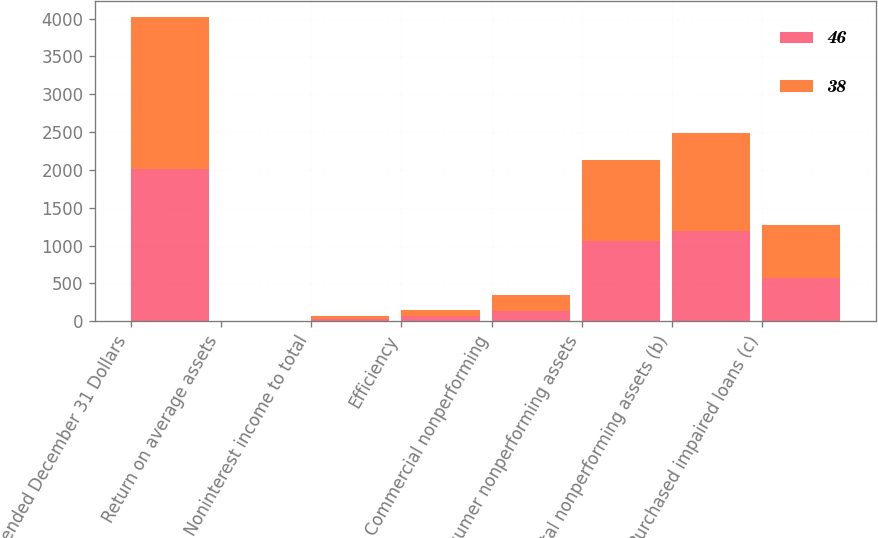<chart> <loc_0><loc_0><loc_500><loc_500><stacked_bar_chart><ecel><fcel>Year ended December 31 Dollars<fcel>Return on average assets<fcel>Noninterest income to total<fcel>Efficiency<fcel>Commercial nonperforming<fcel>Consumer nonperforming assets<fcel>Total nonperforming assets (b)<fcel>Purchased impaired loans (c)<nl><fcel>46<fcel>2014<fcel>0.97<fcel>35<fcel>76<fcel>139<fcel>1059<fcel>1198<fcel>575<nl><fcel>38<fcel>2013<fcel>0.73<fcel>33<fcel>75<fcel>208<fcel>1077<fcel>1285<fcel>692<nl></chart> 